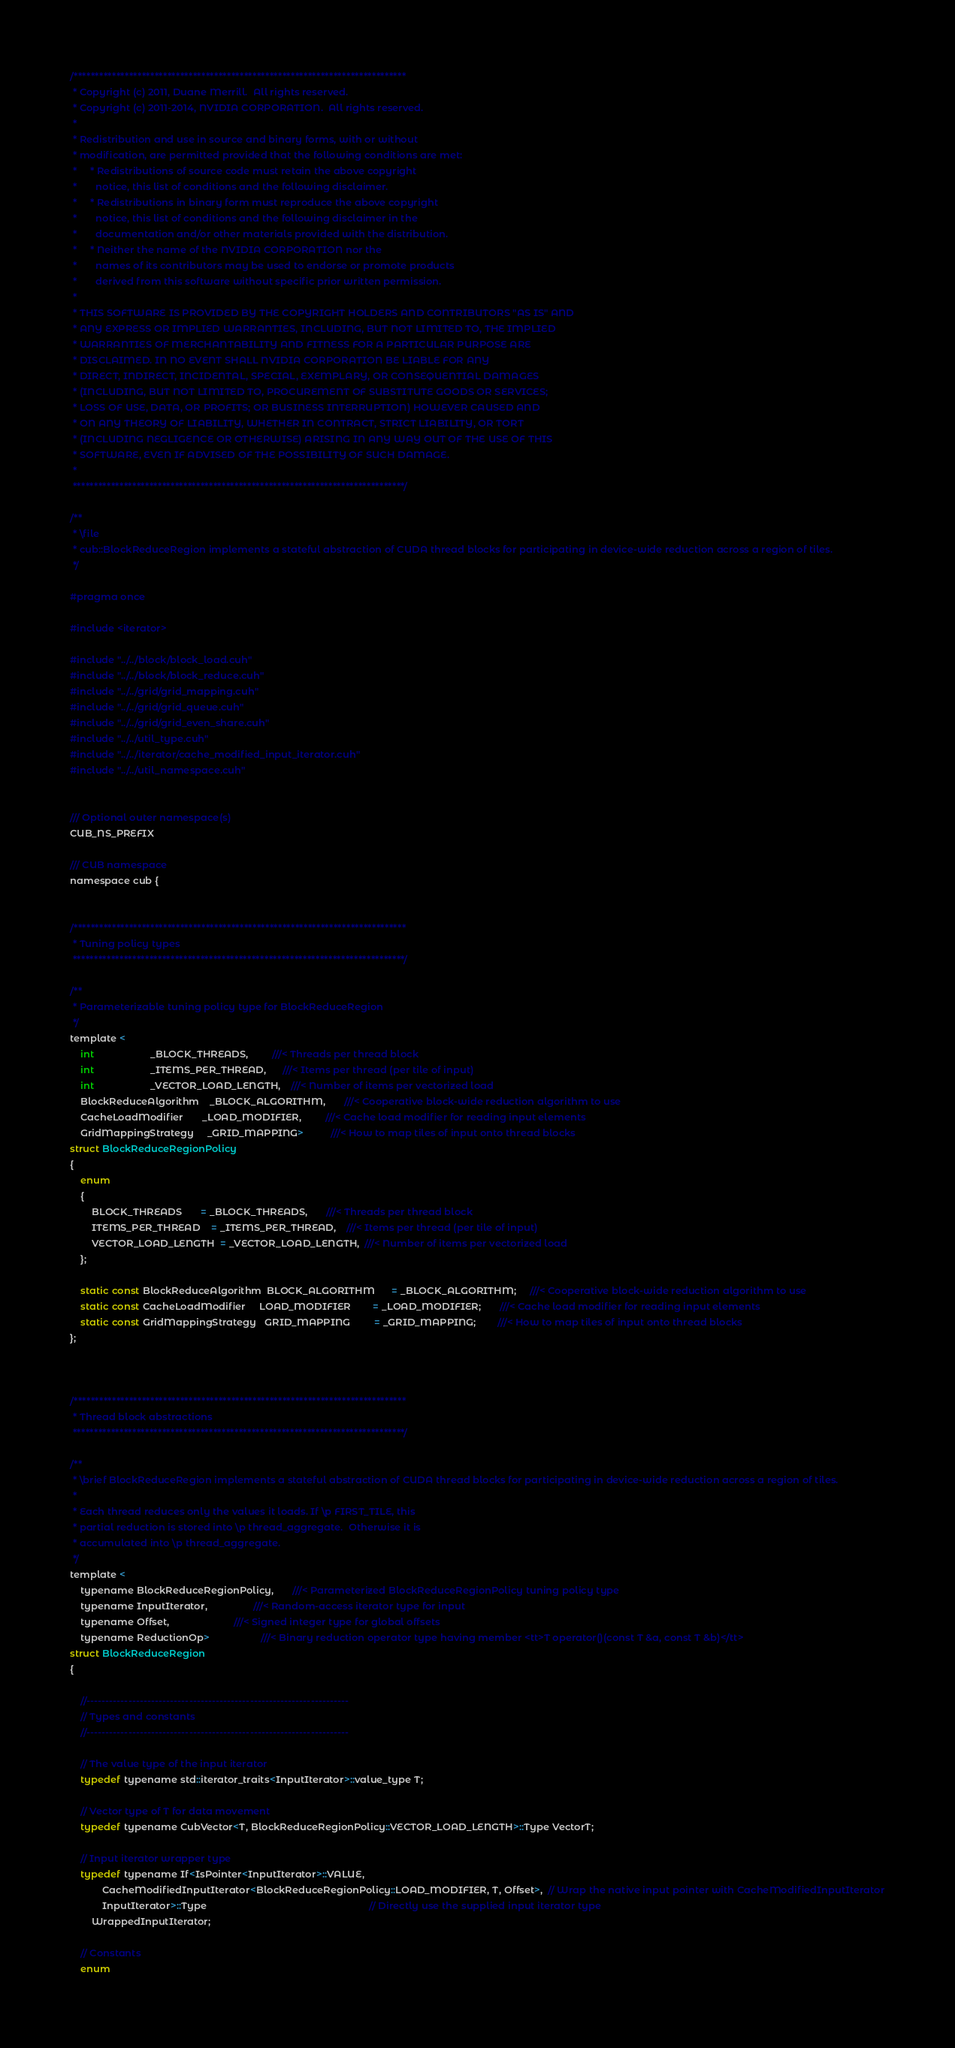Convert code to text. <code><loc_0><loc_0><loc_500><loc_500><_Cuda_>/******************************************************************************
 * Copyright (c) 2011, Duane Merrill.  All rights reserved.
 * Copyright (c) 2011-2014, NVIDIA CORPORATION.  All rights reserved.
 *
 * Redistribution and use in source and binary forms, with or without
 * modification, are permitted provided that the following conditions are met:
 *     * Redistributions of source code must retain the above copyright
 *       notice, this list of conditions and the following disclaimer.
 *     * Redistributions in binary form must reproduce the above copyright
 *       notice, this list of conditions and the following disclaimer in the
 *       documentation and/or other materials provided with the distribution.
 *     * Neither the name of the NVIDIA CORPORATION nor the
 *       names of its contributors may be used to endorse or promote products
 *       derived from this software without specific prior written permission.
 *
 * THIS SOFTWARE IS PROVIDED BY THE COPYRIGHT HOLDERS AND CONTRIBUTORS "AS IS" AND
 * ANY EXPRESS OR IMPLIED WARRANTIES, INCLUDING, BUT NOT LIMITED TO, THE IMPLIED
 * WARRANTIES OF MERCHANTABILITY AND FITNESS FOR A PARTICULAR PURPOSE ARE
 * DISCLAIMED. IN NO EVENT SHALL NVIDIA CORPORATION BE LIABLE FOR ANY
 * DIRECT, INDIRECT, INCIDENTAL, SPECIAL, EXEMPLARY, OR CONSEQUENTIAL DAMAGES
 * (INCLUDING, BUT NOT LIMITED TO, PROCUREMENT OF SUBSTITUTE GOODS OR SERVICES;
 * LOSS OF USE, DATA, OR PROFITS; OR BUSINESS INTERRUPTION) HOWEVER CAUSED AND
 * ON ANY THEORY OF LIABILITY, WHETHER IN CONTRACT, STRICT LIABILITY, OR TORT
 * (INCLUDING NEGLIGENCE OR OTHERWISE) ARISING IN ANY WAY OUT OF THE USE OF THIS
 * SOFTWARE, EVEN IF ADVISED OF THE POSSIBILITY OF SUCH DAMAGE.
 *
 ******************************************************************************/

/**
 * \file
 * cub::BlockReduceRegion implements a stateful abstraction of CUDA thread blocks for participating in device-wide reduction across a region of tiles.
 */

#pragma once

#include <iterator>

#include "../../block/block_load.cuh"
#include "../../block/block_reduce.cuh"
#include "../../grid/grid_mapping.cuh"
#include "../../grid/grid_queue.cuh"
#include "../../grid/grid_even_share.cuh"
#include "../../util_type.cuh"
#include "../../iterator/cache_modified_input_iterator.cuh"
#include "../../util_namespace.cuh"


/// Optional outer namespace(s)
CUB_NS_PREFIX

/// CUB namespace
namespace cub {


/******************************************************************************
 * Tuning policy types
 ******************************************************************************/

/**
 * Parameterizable tuning policy type for BlockReduceRegion
 */
template <
    int                     _BLOCK_THREADS,         ///< Threads per thread block
    int                     _ITEMS_PER_THREAD,      ///< Items per thread (per tile of input)
    int                     _VECTOR_LOAD_LENGTH,    ///< Number of items per vectorized load
    BlockReduceAlgorithm    _BLOCK_ALGORITHM,       ///< Cooperative block-wide reduction algorithm to use
    CacheLoadModifier       _LOAD_MODIFIER,         ///< Cache load modifier for reading input elements
    GridMappingStrategy     _GRID_MAPPING>          ///< How to map tiles of input onto thread blocks
struct BlockReduceRegionPolicy
{
    enum
    {
        BLOCK_THREADS       = _BLOCK_THREADS,       ///< Threads per thread block
        ITEMS_PER_THREAD    = _ITEMS_PER_THREAD,    ///< Items per thread (per tile of input)
        VECTOR_LOAD_LENGTH  = _VECTOR_LOAD_LENGTH,  ///< Number of items per vectorized load
    };

    static const BlockReduceAlgorithm  BLOCK_ALGORITHM      = _BLOCK_ALGORITHM;     ///< Cooperative block-wide reduction algorithm to use
    static const CacheLoadModifier     LOAD_MODIFIER        = _LOAD_MODIFIER;       ///< Cache load modifier for reading input elements
    static const GridMappingStrategy   GRID_MAPPING         = _GRID_MAPPING;        ///< How to map tiles of input onto thread blocks
};



/******************************************************************************
 * Thread block abstractions
 ******************************************************************************/

/**
 * \brief BlockReduceRegion implements a stateful abstraction of CUDA thread blocks for participating in device-wide reduction across a region of tiles.
 *
 * Each thread reduces only the values it loads. If \p FIRST_TILE, this
 * partial reduction is stored into \p thread_aggregate.  Otherwise it is
 * accumulated into \p thread_aggregate.
 */
template <
    typename BlockReduceRegionPolicy,       ///< Parameterized BlockReduceRegionPolicy tuning policy type
    typename InputIterator,                 ///< Random-access iterator type for input
    typename Offset,                        ///< Signed integer type for global offsets
    typename ReductionOp>                   ///< Binary reduction operator type having member <tt>T operator()(const T &a, const T &b)</tt>
struct BlockReduceRegion
{

    //---------------------------------------------------------------------
    // Types and constants
    //---------------------------------------------------------------------

    // The value type of the input iterator
    typedef typename std::iterator_traits<InputIterator>::value_type T;

    // Vector type of T for data movement
    typedef typename CubVector<T, BlockReduceRegionPolicy::VECTOR_LOAD_LENGTH>::Type VectorT;

    // Input iterator wrapper type
    typedef typename If<IsPointer<InputIterator>::VALUE,
            CacheModifiedInputIterator<BlockReduceRegionPolicy::LOAD_MODIFIER, T, Offset>,  // Wrap the native input pointer with CacheModifiedInputIterator
            InputIterator>::Type                                                            // Directly use the supplied input iterator type
        WrappedInputIterator;

    // Constants
    enum</code> 